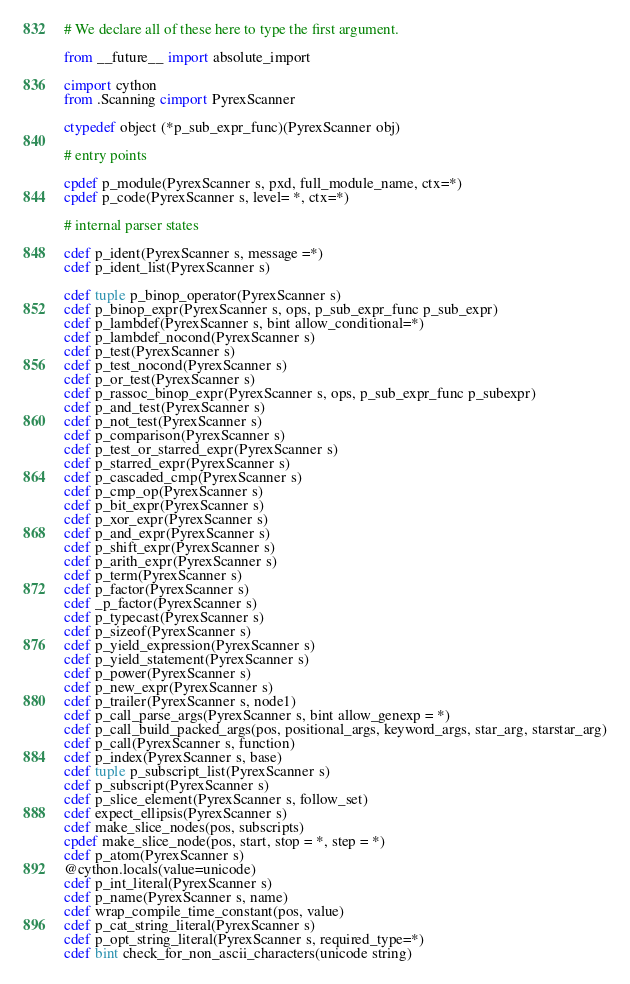Convert code to text. <code><loc_0><loc_0><loc_500><loc_500><_Cython_># We declare all of these here to type the first argument.

from __future__ import absolute_import

cimport cython
from .Scanning cimport PyrexScanner

ctypedef object (*p_sub_expr_func)(PyrexScanner obj)

# entry points

cpdef p_module(PyrexScanner s, pxd, full_module_name, ctx=*)
cpdef p_code(PyrexScanner s, level= *, ctx=*)

# internal parser states

cdef p_ident(PyrexScanner s, message =*)
cdef p_ident_list(PyrexScanner s)

cdef tuple p_binop_operator(PyrexScanner s)
cdef p_binop_expr(PyrexScanner s, ops, p_sub_expr_func p_sub_expr)
cdef p_lambdef(PyrexScanner s, bint allow_conditional=*)
cdef p_lambdef_nocond(PyrexScanner s)
cdef p_test(PyrexScanner s)
cdef p_test_nocond(PyrexScanner s)
cdef p_or_test(PyrexScanner s)
cdef p_rassoc_binop_expr(PyrexScanner s, ops, p_sub_expr_func p_subexpr)
cdef p_and_test(PyrexScanner s)
cdef p_not_test(PyrexScanner s)
cdef p_comparison(PyrexScanner s)
cdef p_test_or_starred_expr(PyrexScanner s)
cdef p_starred_expr(PyrexScanner s)
cdef p_cascaded_cmp(PyrexScanner s)
cdef p_cmp_op(PyrexScanner s)
cdef p_bit_expr(PyrexScanner s)
cdef p_xor_expr(PyrexScanner s)
cdef p_and_expr(PyrexScanner s)
cdef p_shift_expr(PyrexScanner s)
cdef p_arith_expr(PyrexScanner s)
cdef p_term(PyrexScanner s)
cdef p_factor(PyrexScanner s)
cdef _p_factor(PyrexScanner s)
cdef p_typecast(PyrexScanner s)
cdef p_sizeof(PyrexScanner s)
cdef p_yield_expression(PyrexScanner s)
cdef p_yield_statement(PyrexScanner s)
cdef p_power(PyrexScanner s)
cdef p_new_expr(PyrexScanner s)
cdef p_trailer(PyrexScanner s, node1)
cdef p_call_parse_args(PyrexScanner s, bint allow_genexp = *)
cdef p_call_build_packed_args(pos, positional_args, keyword_args, star_arg, starstar_arg)
cdef p_call(PyrexScanner s, function)
cdef p_index(PyrexScanner s, base)
cdef tuple p_subscript_list(PyrexScanner s)
cdef p_subscript(PyrexScanner s)
cdef p_slice_element(PyrexScanner s, follow_set)
cdef expect_ellipsis(PyrexScanner s)
cdef make_slice_nodes(pos, subscripts)
cpdef make_slice_node(pos, start, stop = *, step = *)
cdef p_atom(PyrexScanner s)
@cython.locals(value=unicode)
cdef p_int_literal(PyrexScanner s)
cdef p_name(PyrexScanner s, name)
cdef wrap_compile_time_constant(pos, value)
cdef p_cat_string_literal(PyrexScanner s)
cdef p_opt_string_literal(PyrexScanner s, required_type=*)
cdef bint check_for_non_ascii_characters(unicode string)</code> 